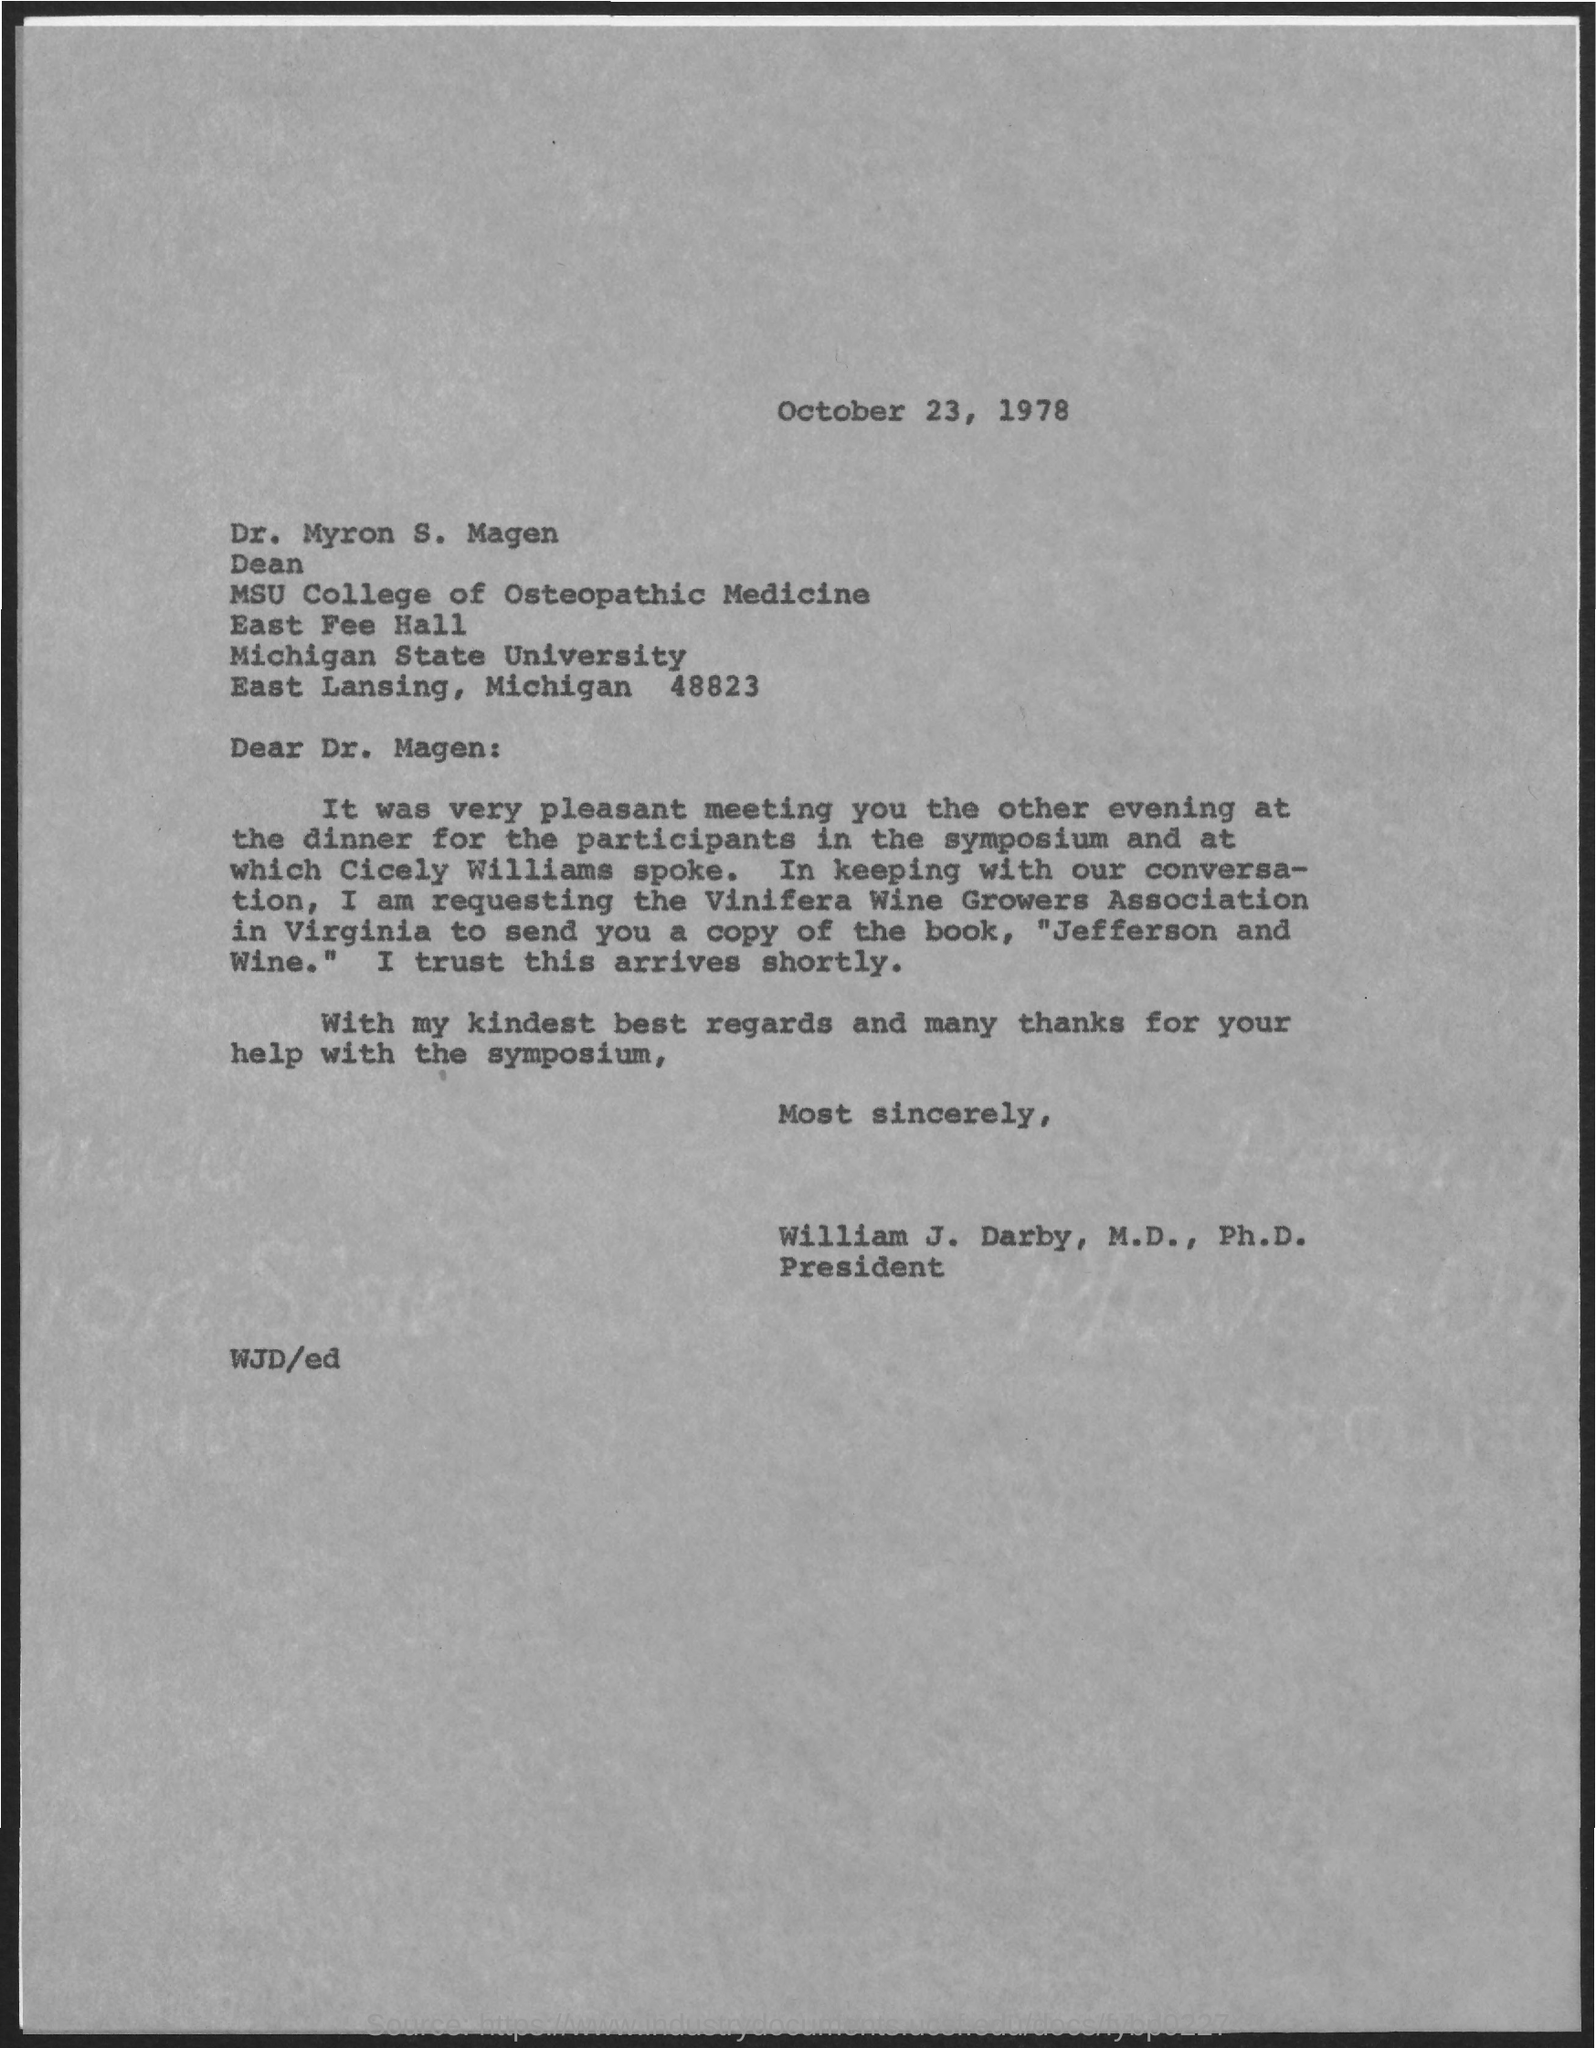Outline some significant characteristics in this image. The person to whom this letter was written is Dr. Magen. Michigan State University is the name of the university mentioned in the given letter. The date mentioned in the given letter is October 23, 1978. Dr. Myron S. Magen is a member of the MSU College of Osteopathic Medicine. Dr. Myron S. Magen holds the designation of Dean. 